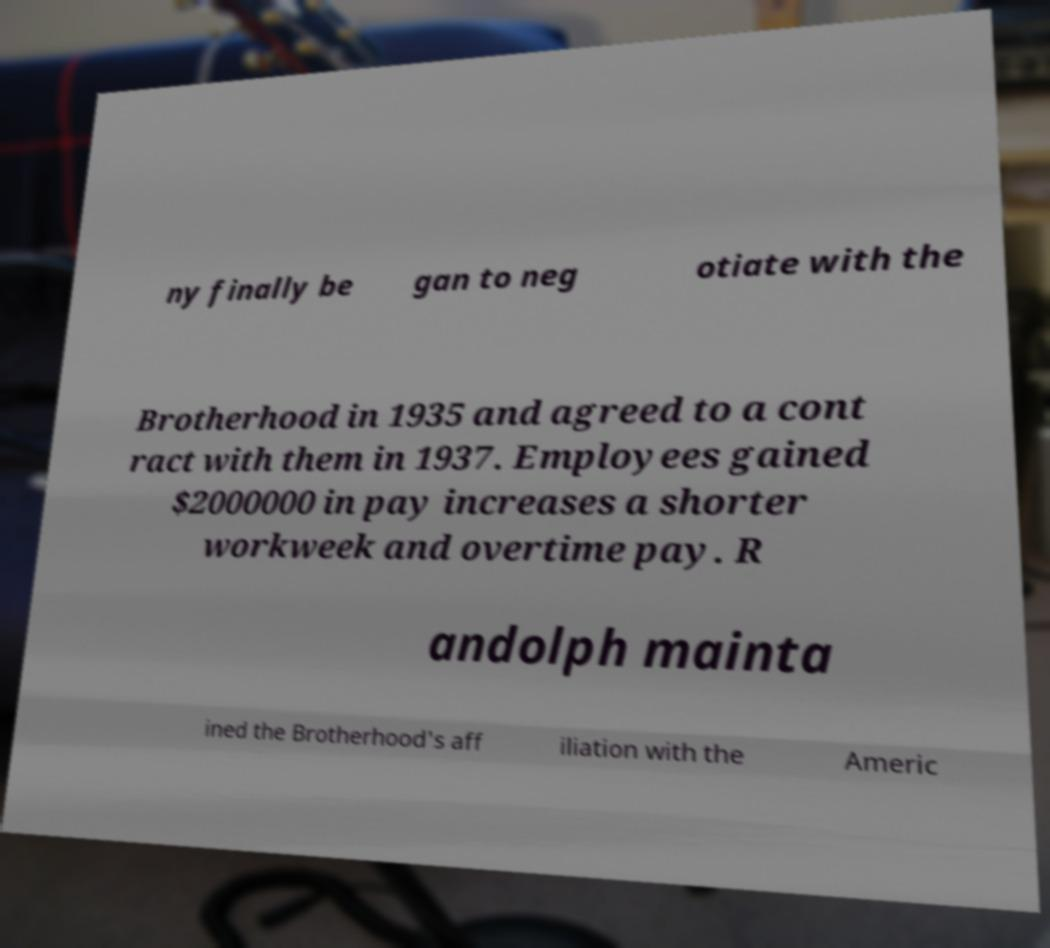I need the written content from this picture converted into text. Can you do that? ny finally be gan to neg otiate with the Brotherhood in 1935 and agreed to a cont ract with them in 1937. Employees gained $2000000 in pay increases a shorter workweek and overtime pay. R andolph mainta ined the Brotherhood's aff iliation with the Americ 